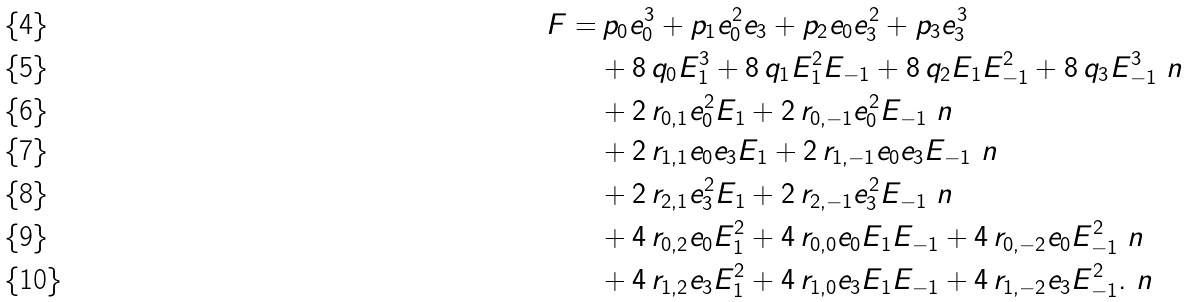<formula> <loc_0><loc_0><loc_500><loc_500>F = & \, p _ { 0 } e _ { 0 } ^ { 3 } + p _ { 1 } e _ { 0 } ^ { 2 } e _ { 3 } + p _ { 2 } e _ { 0 } e _ { 3 } ^ { 2 } + p _ { 3 } e _ { 3 } ^ { 3 } \\ & + 8 \, q _ { 0 } E _ { 1 } ^ { 3 } + 8 \, q _ { 1 } E _ { 1 } ^ { 2 } E _ { - 1 } + 8 \, q _ { 2 } E _ { 1 } E _ { - 1 } ^ { 2 } + 8 \, q _ { 3 } E _ { - 1 } ^ { 3 } \ n \\ & + 2 \, r _ { 0 , 1 } e _ { 0 } ^ { 2 } E _ { 1 } + 2 \, r _ { 0 , - 1 } e _ { 0 } ^ { 2 } E _ { - 1 } \ n \\ & + 2 \, r _ { 1 , 1 } e _ { 0 } e _ { 3 } E _ { 1 } + 2 \, r _ { 1 , - 1 } e _ { 0 } e _ { 3 } E _ { - 1 } \ n \\ & + 2 \, r _ { 2 , 1 } e _ { 3 } ^ { 2 } E _ { 1 } + 2 \, r _ { 2 , - 1 } e _ { 3 } ^ { 2 } E _ { - 1 } \ n \\ & + 4 \, r _ { 0 , 2 } e _ { 0 } E _ { 1 } ^ { 2 } + 4 \, r _ { 0 , 0 } e _ { 0 } E _ { 1 } E _ { - 1 } + 4 \, r _ { 0 , - 2 } e _ { 0 } E _ { - 1 } ^ { 2 } \ n \\ & + 4 \, r _ { 1 , 2 } e _ { 3 } E _ { 1 } ^ { 2 } + 4 \, r _ { 1 , 0 } e _ { 3 } E _ { 1 } E _ { - 1 } + 4 \, r _ { 1 , - 2 } e _ { 3 } E _ { - 1 } ^ { 2 } . \ n</formula> 